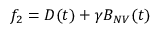Convert formula to latex. <formula><loc_0><loc_0><loc_500><loc_500>{ f _ { 2 } = D ( t ) + \gamma B _ { N V } ( t ) }</formula> 